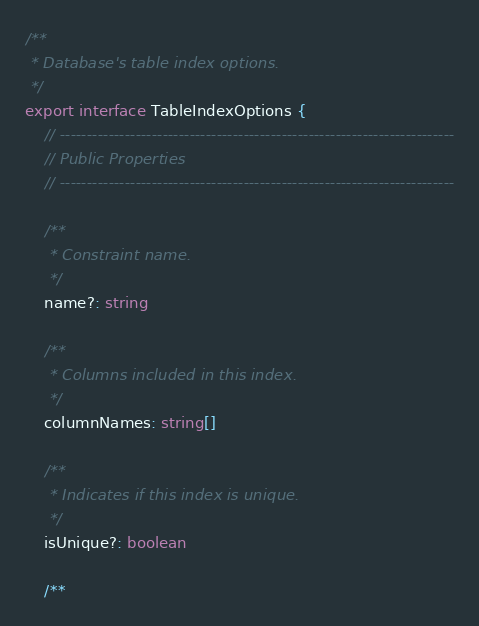<code> <loc_0><loc_0><loc_500><loc_500><_TypeScript_>/**
 * Database's table index options.
 */
export interface TableIndexOptions {
    // -------------------------------------------------------------------------
    // Public Properties
    // -------------------------------------------------------------------------

    /**
     * Constraint name.
     */
    name?: string

    /**
     * Columns included in this index.
     */
    columnNames: string[]

    /**
     * Indicates if this index is unique.
     */
    isUnique?: boolean

    /**</code> 